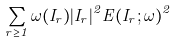Convert formula to latex. <formula><loc_0><loc_0><loc_500><loc_500>\sum _ { r \geq 1 } \omega ( I _ { r } ) | I _ { r } | ^ { 2 } E ( I _ { r } ; \omega ) ^ { 2 }</formula> 